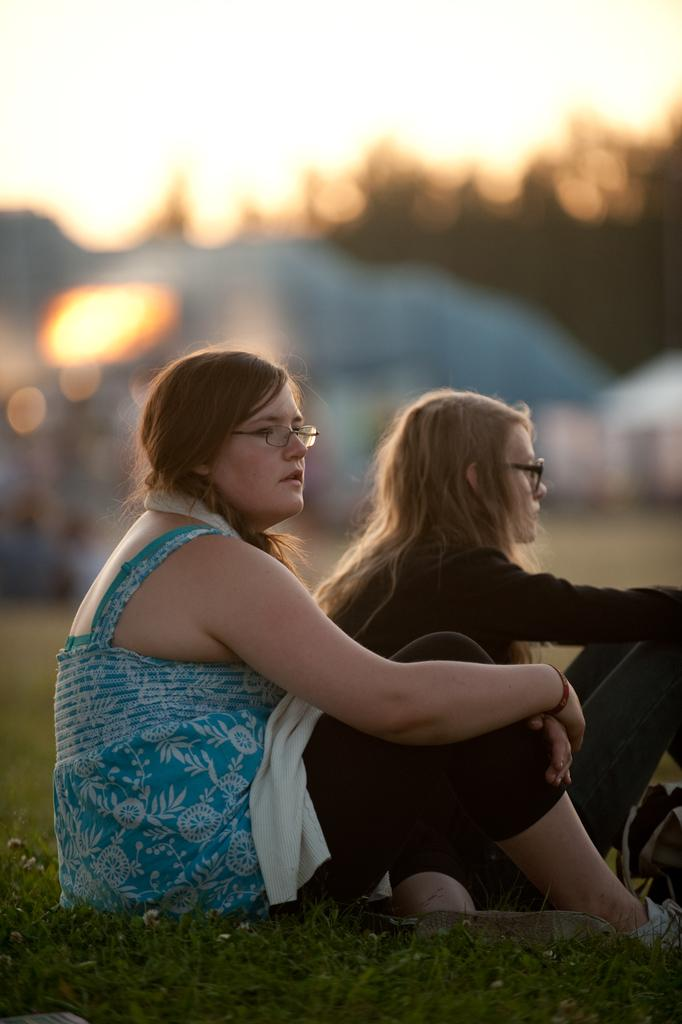How many people are in the image? There are two persons in the image. What are the persons doing in the image? The persons are sitting on the grass. Can you describe the background of the image? The background of the image is blurred. What type of light can be seen shining from the root in the image? There is no light or root present in the image. 